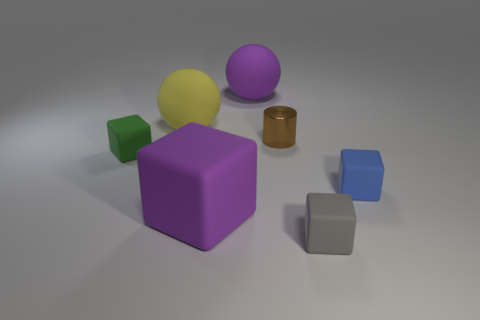The matte cube that is right of the small matte block in front of the big purple thing on the left side of the big purple rubber ball is what color?
Your answer should be compact. Blue. How many other things are there of the same size as the yellow rubber sphere?
Offer a very short reply. 2. Are there any other things that are the same shape as the gray thing?
Make the answer very short. Yes. There is a big matte thing that is the same shape as the small green matte object; what color is it?
Ensure brevity in your answer.  Purple. The large block that is made of the same material as the gray object is what color?
Offer a terse response. Purple. Are there an equal number of large purple rubber balls in front of the tiny gray thing and tiny green metallic spheres?
Give a very brief answer. Yes. There is a object that is left of the yellow rubber ball; is it the same size as the big cube?
Make the answer very short. No. There is a cylinder that is the same size as the green rubber object; what color is it?
Offer a terse response. Brown. There is a small blue rubber thing that is to the right of the purple rubber object behind the blue matte block; is there a small gray thing right of it?
Offer a very short reply. No. What material is the small block that is to the left of the tiny gray matte block?
Keep it short and to the point. Rubber. 